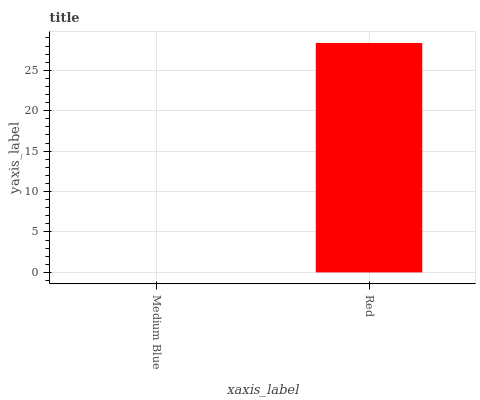Is Medium Blue the minimum?
Answer yes or no. Yes. Is Red the maximum?
Answer yes or no. Yes. Is Red the minimum?
Answer yes or no. No. Is Red greater than Medium Blue?
Answer yes or no. Yes. Is Medium Blue less than Red?
Answer yes or no. Yes. Is Medium Blue greater than Red?
Answer yes or no. No. Is Red less than Medium Blue?
Answer yes or no. No. Is Red the high median?
Answer yes or no. Yes. Is Medium Blue the low median?
Answer yes or no. Yes. Is Medium Blue the high median?
Answer yes or no. No. Is Red the low median?
Answer yes or no. No. 